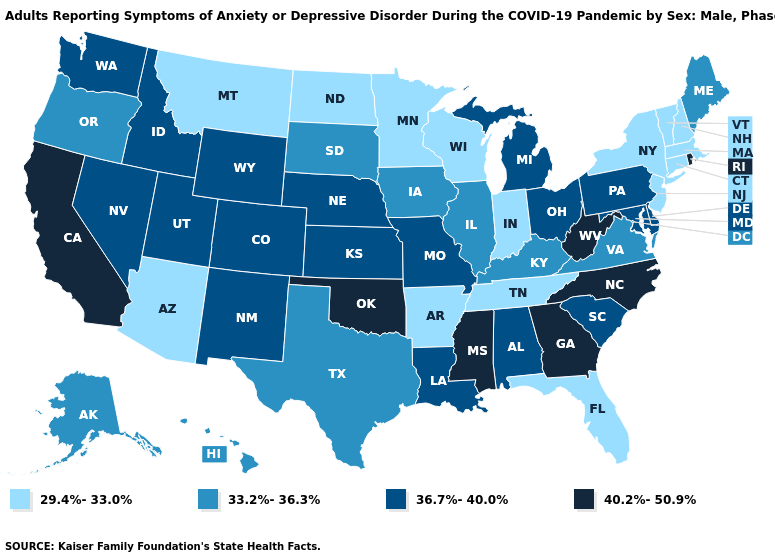Name the states that have a value in the range 40.2%-50.9%?
Keep it brief. California, Georgia, Mississippi, North Carolina, Oklahoma, Rhode Island, West Virginia. Does Vermont have a higher value than Nevada?
Answer briefly. No. What is the value of New Mexico?
Give a very brief answer. 36.7%-40.0%. What is the lowest value in the South?
Short answer required. 29.4%-33.0%. What is the value of Louisiana?
Quick response, please. 36.7%-40.0%. How many symbols are there in the legend?
Answer briefly. 4. Which states hav the highest value in the South?
Write a very short answer. Georgia, Mississippi, North Carolina, Oklahoma, West Virginia. Does Utah have a higher value than New Hampshire?
Give a very brief answer. Yes. What is the value of Kansas?
Concise answer only. 36.7%-40.0%. What is the highest value in the USA?
Short answer required. 40.2%-50.9%. What is the value of Wisconsin?
Be succinct. 29.4%-33.0%. What is the value of California?
Be succinct. 40.2%-50.9%. Among the states that border Georgia , does Tennessee have the lowest value?
Write a very short answer. Yes. Name the states that have a value in the range 29.4%-33.0%?
Answer briefly. Arizona, Arkansas, Connecticut, Florida, Indiana, Massachusetts, Minnesota, Montana, New Hampshire, New Jersey, New York, North Dakota, Tennessee, Vermont, Wisconsin. Name the states that have a value in the range 40.2%-50.9%?
Concise answer only. California, Georgia, Mississippi, North Carolina, Oklahoma, Rhode Island, West Virginia. 